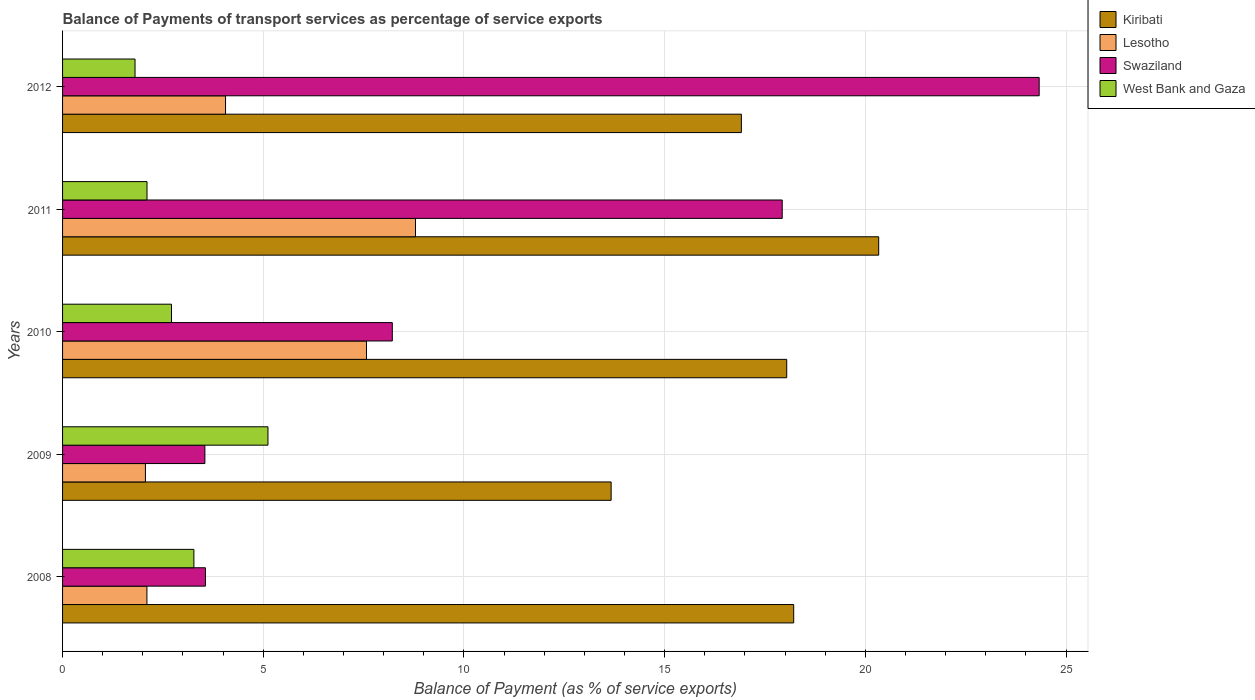How many groups of bars are there?
Your response must be concise. 5. Are the number of bars per tick equal to the number of legend labels?
Your answer should be compact. Yes. How many bars are there on the 2nd tick from the top?
Provide a short and direct response. 4. What is the balance of payments of transport services in Lesotho in 2009?
Provide a short and direct response. 2.06. Across all years, what is the maximum balance of payments of transport services in Lesotho?
Provide a succinct answer. 8.79. Across all years, what is the minimum balance of payments of transport services in West Bank and Gaza?
Your answer should be very brief. 1.81. In which year was the balance of payments of transport services in Lesotho maximum?
Provide a short and direct response. 2011. What is the total balance of payments of transport services in Swaziland in the graph?
Make the answer very short. 57.58. What is the difference between the balance of payments of transport services in Lesotho in 2009 and that in 2012?
Give a very brief answer. -2. What is the difference between the balance of payments of transport services in West Bank and Gaza in 2008 and the balance of payments of transport services in Swaziland in 2012?
Your answer should be compact. -21.06. What is the average balance of payments of transport services in Swaziland per year?
Offer a terse response. 11.52. In the year 2012, what is the difference between the balance of payments of transport services in Lesotho and balance of payments of transport services in West Bank and Gaza?
Ensure brevity in your answer.  2.25. In how many years, is the balance of payments of transport services in Lesotho greater than 17 %?
Your answer should be very brief. 0. What is the ratio of the balance of payments of transport services in Kiribati in 2010 to that in 2012?
Offer a very short reply. 1.07. Is the balance of payments of transport services in Swaziland in 2009 less than that in 2010?
Your answer should be compact. Yes. Is the difference between the balance of payments of transport services in Lesotho in 2009 and 2010 greater than the difference between the balance of payments of transport services in West Bank and Gaza in 2009 and 2010?
Your answer should be compact. No. What is the difference between the highest and the second highest balance of payments of transport services in West Bank and Gaza?
Give a very brief answer. 1.85. What is the difference between the highest and the lowest balance of payments of transport services in Swaziland?
Keep it short and to the point. 20.79. In how many years, is the balance of payments of transport services in Swaziland greater than the average balance of payments of transport services in Swaziland taken over all years?
Keep it short and to the point. 2. Is it the case that in every year, the sum of the balance of payments of transport services in Lesotho and balance of payments of transport services in West Bank and Gaza is greater than the sum of balance of payments of transport services in Swaziland and balance of payments of transport services in Kiribati?
Offer a very short reply. No. What does the 2nd bar from the top in 2010 represents?
Your answer should be compact. Swaziland. What does the 3rd bar from the bottom in 2008 represents?
Keep it short and to the point. Swaziland. How many bars are there?
Ensure brevity in your answer.  20. Are all the bars in the graph horizontal?
Offer a very short reply. Yes. What is the difference between two consecutive major ticks on the X-axis?
Provide a short and direct response. 5. Are the values on the major ticks of X-axis written in scientific E-notation?
Provide a short and direct response. No. How many legend labels are there?
Your response must be concise. 4. How are the legend labels stacked?
Make the answer very short. Vertical. What is the title of the graph?
Your answer should be very brief. Balance of Payments of transport services as percentage of service exports. Does "Paraguay" appear as one of the legend labels in the graph?
Provide a short and direct response. No. What is the label or title of the X-axis?
Make the answer very short. Balance of Payment (as % of service exports). What is the Balance of Payment (as % of service exports) in Kiribati in 2008?
Offer a very short reply. 18.22. What is the Balance of Payment (as % of service exports) of Lesotho in 2008?
Provide a short and direct response. 2.1. What is the Balance of Payment (as % of service exports) in Swaziland in 2008?
Your answer should be very brief. 3.56. What is the Balance of Payment (as % of service exports) in West Bank and Gaza in 2008?
Give a very brief answer. 3.27. What is the Balance of Payment (as % of service exports) in Kiribati in 2009?
Keep it short and to the point. 13.67. What is the Balance of Payment (as % of service exports) in Lesotho in 2009?
Provide a short and direct response. 2.06. What is the Balance of Payment (as % of service exports) in Swaziland in 2009?
Make the answer very short. 3.55. What is the Balance of Payment (as % of service exports) in West Bank and Gaza in 2009?
Give a very brief answer. 5.12. What is the Balance of Payment (as % of service exports) of Kiribati in 2010?
Keep it short and to the point. 18.04. What is the Balance of Payment (as % of service exports) of Lesotho in 2010?
Offer a very short reply. 7.57. What is the Balance of Payment (as % of service exports) of Swaziland in 2010?
Give a very brief answer. 8.22. What is the Balance of Payment (as % of service exports) in West Bank and Gaza in 2010?
Provide a succinct answer. 2.71. What is the Balance of Payment (as % of service exports) in Kiribati in 2011?
Offer a very short reply. 20.33. What is the Balance of Payment (as % of service exports) in Lesotho in 2011?
Provide a succinct answer. 8.79. What is the Balance of Payment (as % of service exports) in Swaziland in 2011?
Give a very brief answer. 17.93. What is the Balance of Payment (as % of service exports) of West Bank and Gaza in 2011?
Make the answer very short. 2.1. What is the Balance of Payment (as % of service exports) in Kiribati in 2012?
Provide a short and direct response. 16.91. What is the Balance of Payment (as % of service exports) in Lesotho in 2012?
Give a very brief answer. 4.06. What is the Balance of Payment (as % of service exports) in Swaziland in 2012?
Give a very brief answer. 24.33. What is the Balance of Payment (as % of service exports) in West Bank and Gaza in 2012?
Make the answer very short. 1.81. Across all years, what is the maximum Balance of Payment (as % of service exports) in Kiribati?
Make the answer very short. 20.33. Across all years, what is the maximum Balance of Payment (as % of service exports) of Lesotho?
Make the answer very short. 8.79. Across all years, what is the maximum Balance of Payment (as % of service exports) of Swaziland?
Provide a succinct answer. 24.33. Across all years, what is the maximum Balance of Payment (as % of service exports) in West Bank and Gaza?
Provide a succinct answer. 5.12. Across all years, what is the minimum Balance of Payment (as % of service exports) of Kiribati?
Your answer should be very brief. 13.67. Across all years, what is the minimum Balance of Payment (as % of service exports) in Lesotho?
Keep it short and to the point. 2.06. Across all years, what is the minimum Balance of Payment (as % of service exports) of Swaziland?
Provide a succinct answer. 3.55. Across all years, what is the minimum Balance of Payment (as % of service exports) in West Bank and Gaza?
Your response must be concise. 1.81. What is the total Balance of Payment (as % of service exports) in Kiribati in the graph?
Keep it short and to the point. 87.17. What is the total Balance of Payment (as % of service exports) of Lesotho in the graph?
Provide a succinct answer. 24.59. What is the total Balance of Payment (as % of service exports) in Swaziland in the graph?
Your answer should be very brief. 57.58. What is the total Balance of Payment (as % of service exports) of West Bank and Gaza in the graph?
Offer a terse response. 15.01. What is the difference between the Balance of Payment (as % of service exports) in Kiribati in 2008 and that in 2009?
Provide a short and direct response. 4.55. What is the difference between the Balance of Payment (as % of service exports) in Lesotho in 2008 and that in 2009?
Give a very brief answer. 0.04. What is the difference between the Balance of Payment (as % of service exports) in Swaziland in 2008 and that in 2009?
Keep it short and to the point. 0.01. What is the difference between the Balance of Payment (as % of service exports) in West Bank and Gaza in 2008 and that in 2009?
Give a very brief answer. -1.85. What is the difference between the Balance of Payment (as % of service exports) in Kiribati in 2008 and that in 2010?
Ensure brevity in your answer.  0.17. What is the difference between the Balance of Payment (as % of service exports) in Lesotho in 2008 and that in 2010?
Provide a short and direct response. -5.47. What is the difference between the Balance of Payment (as % of service exports) of Swaziland in 2008 and that in 2010?
Make the answer very short. -4.66. What is the difference between the Balance of Payment (as % of service exports) in West Bank and Gaza in 2008 and that in 2010?
Offer a very short reply. 0.56. What is the difference between the Balance of Payment (as % of service exports) in Kiribati in 2008 and that in 2011?
Make the answer very short. -2.12. What is the difference between the Balance of Payment (as % of service exports) in Lesotho in 2008 and that in 2011?
Keep it short and to the point. -6.69. What is the difference between the Balance of Payment (as % of service exports) in Swaziland in 2008 and that in 2011?
Provide a succinct answer. -14.37. What is the difference between the Balance of Payment (as % of service exports) of West Bank and Gaza in 2008 and that in 2011?
Make the answer very short. 1.17. What is the difference between the Balance of Payment (as % of service exports) in Kiribati in 2008 and that in 2012?
Your response must be concise. 1.3. What is the difference between the Balance of Payment (as % of service exports) of Lesotho in 2008 and that in 2012?
Give a very brief answer. -1.96. What is the difference between the Balance of Payment (as % of service exports) in Swaziland in 2008 and that in 2012?
Ensure brevity in your answer.  -20.77. What is the difference between the Balance of Payment (as % of service exports) in West Bank and Gaza in 2008 and that in 2012?
Provide a succinct answer. 1.47. What is the difference between the Balance of Payment (as % of service exports) of Kiribati in 2009 and that in 2010?
Offer a very short reply. -4.37. What is the difference between the Balance of Payment (as % of service exports) of Lesotho in 2009 and that in 2010?
Make the answer very short. -5.51. What is the difference between the Balance of Payment (as % of service exports) of Swaziland in 2009 and that in 2010?
Offer a very short reply. -4.67. What is the difference between the Balance of Payment (as % of service exports) in West Bank and Gaza in 2009 and that in 2010?
Your response must be concise. 2.4. What is the difference between the Balance of Payment (as % of service exports) in Kiribati in 2009 and that in 2011?
Your response must be concise. -6.67. What is the difference between the Balance of Payment (as % of service exports) in Lesotho in 2009 and that in 2011?
Provide a succinct answer. -6.73. What is the difference between the Balance of Payment (as % of service exports) of Swaziland in 2009 and that in 2011?
Give a very brief answer. -14.38. What is the difference between the Balance of Payment (as % of service exports) in West Bank and Gaza in 2009 and that in 2011?
Give a very brief answer. 3.01. What is the difference between the Balance of Payment (as % of service exports) of Kiribati in 2009 and that in 2012?
Your answer should be compact. -3.24. What is the difference between the Balance of Payment (as % of service exports) of Lesotho in 2009 and that in 2012?
Offer a very short reply. -2. What is the difference between the Balance of Payment (as % of service exports) in Swaziland in 2009 and that in 2012?
Give a very brief answer. -20.79. What is the difference between the Balance of Payment (as % of service exports) of West Bank and Gaza in 2009 and that in 2012?
Your answer should be very brief. 3.31. What is the difference between the Balance of Payment (as % of service exports) of Kiribati in 2010 and that in 2011?
Your response must be concise. -2.29. What is the difference between the Balance of Payment (as % of service exports) in Lesotho in 2010 and that in 2011?
Give a very brief answer. -1.22. What is the difference between the Balance of Payment (as % of service exports) of Swaziland in 2010 and that in 2011?
Keep it short and to the point. -9.71. What is the difference between the Balance of Payment (as % of service exports) in West Bank and Gaza in 2010 and that in 2011?
Offer a terse response. 0.61. What is the difference between the Balance of Payment (as % of service exports) in Kiribati in 2010 and that in 2012?
Give a very brief answer. 1.13. What is the difference between the Balance of Payment (as % of service exports) of Lesotho in 2010 and that in 2012?
Offer a very short reply. 3.51. What is the difference between the Balance of Payment (as % of service exports) in Swaziland in 2010 and that in 2012?
Keep it short and to the point. -16.12. What is the difference between the Balance of Payment (as % of service exports) in West Bank and Gaza in 2010 and that in 2012?
Your answer should be compact. 0.91. What is the difference between the Balance of Payment (as % of service exports) of Kiribati in 2011 and that in 2012?
Offer a terse response. 3.42. What is the difference between the Balance of Payment (as % of service exports) of Lesotho in 2011 and that in 2012?
Your answer should be very brief. 4.73. What is the difference between the Balance of Payment (as % of service exports) in Swaziland in 2011 and that in 2012?
Offer a terse response. -6.4. What is the difference between the Balance of Payment (as % of service exports) in West Bank and Gaza in 2011 and that in 2012?
Offer a terse response. 0.3. What is the difference between the Balance of Payment (as % of service exports) of Kiribati in 2008 and the Balance of Payment (as % of service exports) of Lesotho in 2009?
Provide a short and direct response. 16.15. What is the difference between the Balance of Payment (as % of service exports) in Kiribati in 2008 and the Balance of Payment (as % of service exports) in Swaziland in 2009?
Provide a short and direct response. 14.67. What is the difference between the Balance of Payment (as % of service exports) of Kiribati in 2008 and the Balance of Payment (as % of service exports) of West Bank and Gaza in 2009?
Your answer should be compact. 13.1. What is the difference between the Balance of Payment (as % of service exports) in Lesotho in 2008 and the Balance of Payment (as % of service exports) in Swaziland in 2009?
Your answer should be compact. -1.44. What is the difference between the Balance of Payment (as % of service exports) of Lesotho in 2008 and the Balance of Payment (as % of service exports) of West Bank and Gaza in 2009?
Offer a terse response. -3.02. What is the difference between the Balance of Payment (as % of service exports) in Swaziland in 2008 and the Balance of Payment (as % of service exports) in West Bank and Gaza in 2009?
Your response must be concise. -1.56. What is the difference between the Balance of Payment (as % of service exports) of Kiribati in 2008 and the Balance of Payment (as % of service exports) of Lesotho in 2010?
Provide a short and direct response. 10.64. What is the difference between the Balance of Payment (as % of service exports) in Kiribati in 2008 and the Balance of Payment (as % of service exports) in Swaziland in 2010?
Your answer should be compact. 10. What is the difference between the Balance of Payment (as % of service exports) in Kiribati in 2008 and the Balance of Payment (as % of service exports) in West Bank and Gaza in 2010?
Your answer should be compact. 15.5. What is the difference between the Balance of Payment (as % of service exports) in Lesotho in 2008 and the Balance of Payment (as % of service exports) in Swaziland in 2010?
Provide a succinct answer. -6.11. What is the difference between the Balance of Payment (as % of service exports) of Lesotho in 2008 and the Balance of Payment (as % of service exports) of West Bank and Gaza in 2010?
Keep it short and to the point. -0.61. What is the difference between the Balance of Payment (as % of service exports) in Swaziland in 2008 and the Balance of Payment (as % of service exports) in West Bank and Gaza in 2010?
Make the answer very short. 0.85. What is the difference between the Balance of Payment (as % of service exports) in Kiribati in 2008 and the Balance of Payment (as % of service exports) in Lesotho in 2011?
Offer a very short reply. 9.42. What is the difference between the Balance of Payment (as % of service exports) in Kiribati in 2008 and the Balance of Payment (as % of service exports) in Swaziland in 2011?
Ensure brevity in your answer.  0.29. What is the difference between the Balance of Payment (as % of service exports) of Kiribati in 2008 and the Balance of Payment (as % of service exports) of West Bank and Gaza in 2011?
Ensure brevity in your answer.  16.11. What is the difference between the Balance of Payment (as % of service exports) in Lesotho in 2008 and the Balance of Payment (as % of service exports) in Swaziland in 2011?
Offer a terse response. -15.83. What is the difference between the Balance of Payment (as % of service exports) in Lesotho in 2008 and the Balance of Payment (as % of service exports) in West Bank and Gaza in 2011?
Your response must be concise. -0. What is the difference between the Balance of Payment (as % of service exports) in Swaziland in 2008 and the Balance of Payment (as % of service exports) in West Bank and Gaza in 2011?
Offer a terse response. 1.46. What is the difference between the Balance of Payment (as % of service exports) of Kiribati in 2008 and the Balance of Payment (as % of service exports) of Lesotho in 2012?
Your answer should be very brief. 14.16. What is the difference between the Balance of Payment (as % of service exports) in Kiribati in 2008 and the Balance of Payment (as % of service exports) in Swaziland in 2012?
Your response must be concise. -6.12. What is the difference between the Balance of Payment (as % of service exports) of Kiribati in 2008 and the Balance of Payment (as % of service exports) of West Bank and Gaza in 2012?
Your response must be concise. 16.41. What is the difference between the Balance of Payment (as % of service exports) in Lesotho in 2008 and the Balance of Payment (as % of service exports) in Swaziland in 2012?
Provide a succinct answer. -22.23. What is the difference between the Balance of Payment (as % of service exports) of Lesotho in 2008 and the Balance of Payment (as % of service exports) of West Bank and Gaza in 2012?
Your answer should be compact. 0.3. What is the difference between the Balance of Payment (as % of service exports) of Swaziland in 2008 and the Balance of Payment (as % of service exports) of West Bank and Gaza in 2012?
Provide a succinct answer. 1.75. What is the difference between the Balance of Payment (as % of service exports) in Kiribati in 2009 and the Balance of Payment (as % of service exports) in Lesotho in 2010?
Provide a short and direct response. 6.1. What is the difference between the Balance of Payment (as % of service exports) in Kiribati in 2009 and the Balance of Payment (as % of service exports) in Swaziland in 2010?
Your answer should be compact. 5.45. What is the difference between the Balance of Payment (as % of service exports) in Kiribati in 2009 and the Balance of Payment (as % of service exports) in West Bank and Gaza in 2010?
Offer a very short reply. 10.95. What is the difference between the Balance of Payment (as % of service exports) of Lesotho in 2009 and the Balance of Payment (as % of service exports) of Swaziland in 2010?
Your answer should be compact. -6.15. What is the difference between the Balance of Payment (as % of service exports) in Lesotho in 2009 and the Balance of Payment (as % of service exports) in West Bank and Gaza in 2010?
Offer a terse response. -0.65. What is the difference between the Balance of Payment (as % of service exports) of Swaziland in 2009 and the Balance of Payment (as % of service exports) of West Bank and Gaza in 2010?
Ensure brevity in your answer.  0.83. What is the difference between the Balance of Payment (as % of service exports) of Kiribati in 2009 and the Balance of Payment (as % of service exports) of Lesotho in 2011?
Ensure brevity in your answer.  4.87. What is the difference between the Balance of Payment (as % of service exports) of Kiribati in 2009 and the Balance of Payment (as % of service exports) of Swaziland in 2011?
Make the answer very short. -4.26. What is the difference between the Balance of Payment (as % of service exports) of Kiribati in 2009 and the Balance of Payment (as % of service exports) of West Bank and Gaza in 2011?
Ensure brevity in your answer.  11.56. What is the difference between the Balance of Payment (as % of service exports) in Lesotho in 2009 and the Balance of Payment (as % of service exports) in Swaziland in 2011?
Your answer should be very brief. -15.87. What is the difference between the Balance of Payment (as % of service exports) in Lesotho in 2009 and the Balance of Payment (as % of service exports) in West Bank and Gaza in 2011?
Offer a terse response. -0.04. What is the difference between the Balance of Payment (as % of service exports) of Swaziland in 2009 and the Balance of Payment (as % of service exports) of West Bank and Gaza in 2011?
Give a very brief answer. 1.44. What is the difference between the Balance of Payment (as % of service exports) in Kiribati in 2009 and the Balance of Payment (as % of service exports) in Lesotho in 2012?
Provide a short and direct response. 9.61. What is the difference between the Balance of Payment (as % of service exports) of Kiribati in 2009 and the Balance of Payment (as % of service exports) of Swaziland in 2012?
Make the answer very short. -10.66. What is the difference between the Balance of Payment (as % of service exports) in Kiribati in 2009 and the Balance of Payment (as % of service exports) in West Bank and Gaza in 2012?
Make the answer very short. 11.86. What is the difference between the Balance of Payment (as % of service exports) of Lesotho in 2009 and the Balance of Payment (as % of service exports) of Swaziland in 2012?
Ensure brevity in your answer.  -22.27. What is the difference between the Balance of Payment (as % of service exports) of Lesotho in 2009 and the Balance of Payment (as % of service exports) of West Bank and Gaza in 2012?
Your answer should be compact. 0.26. What is the difference between the Balance of Payment (as % of service exports) of Swaziland in 2009 and the Balance of Payment (as % of service exports) of West Bank and Gaza in 2012?
Your response must be concise. 1.74. What is the difference between the Balance of Payment (as % of service exports) in Kiribati in 2010 and the Balance of Payment (as % of service exports) in Lesotho in 2011?
Offer a very short reply. 9.25. What is the difference between the Balance of Payment (as % of service exports) of Kiribati in 2010 and the Balance of Payment (as % of service exports) of Swaziland in 2011?
Offer a very short reply. 0.11. What is the difference between the Balance of Payment (as % of service exports) of Kiribati in 2010 and the Balance of Payment (as % of service exports) of West Bank and Gaza in 2011?
Offer a terse response. 15.94. What is the difference between the Balance of Payment (as % of service exports) in Lesotho in 2010 and the Balance of Payment (as % of service exports) in Swaziland in 2011?
Offer a terse response. -10.36. What is the difference between the Balance of Payment (as % of service exports) in Lesotho in 2010 and the Balance of Payment (as % of service exports) in West Bank and Gaza in 2011?
Make the answer very short. 5.47. What is the difference between the Balance of Payment (as % of service exports) in Swaziland in 2010 and the Balance of Payment (as % of service exports) in West Bank and Gaza in 2011?
Ensure brevity in your answer.  6.11. What is the difference between the Balance of Payment (as % of service exports) in Kiribati in 2010 and the Balance of Payment (as % of service exports) in Lesotho in 2012?
Your response must be concise. 13.98. What is the difference between the Balance of Payment (as % of service exports) in Kiribati in 2010 and the Balance of Payment (as % of service exports) in Swaziland in 2012?
Offer a very short reply. -6.29. What is the difference between the Balance of Payment (as % of service exports) of Kiribati in 2010 and the Balance of Payment (as % of service exports) of West Bank and Gaza in 2012?
Ensure brevity in your answer.  16.24. What is the difference between the Balance of Payment (as % of service exports) in Lesotho in 2010 and the Balance of Payment (as % of service exports) in Swaziland in 2012?
Your answer should be very brief. -16.76. What is the difference between the Balance of Payment (as % of service exports) of Lesotho in 2010 and the Balance of Payment (as % of service exports) of West Bank and Gaza in 2012?
Make the answer very short. 5.77. What is the difference between the Balance of Payment (as % of service exports) of Swaziland in 2010 and the Balance of Payment (as % of service exports) of West Bank and Gaza in 2012?
Give a very brief answer. 6.41. What is the difference between the Balance of Payment (as % of service exports) of Kiribati in 2011 and the Balance of Payment (as % of service exports) of Lesotho in 2012?
Your response must be concise. 16.27. What is the difference between the Balance of Payment (as % of service exports) in Kiribati in 2011 and the Balance of Payment (as % of service exports) in Swaziland in 2012?
Make the answer very short. -4. What is the difference between the Balance of Payment (as % of service exports) of Kiribati in 2011 and the Balance of Payment (as % of service exports) of West Bank and Gaza in 2012?
Offer a very short reply. 18.53. What is the difference between the Balance of Payment (as % of service exports) of Lesotho in 2011 and the Balance of Payment (as % of service exports) of Swaziland in 2012?
Give a very brief answer. -15.54. What is the difference between the Balance of Payment (as % of service exports) in Lesotho in 2011 and the Balance of Payment (as % of service exports) in West Bank and Gaza in 2012?
Ensure brevity in your answer.  6.99. What is the difference between the Balance of Payment (as % of service exports) in Swaziland in 2011 and the Balance of Payment (as % of service exports) in West Bank and Gaza in 2012?
Keep it short and to the point. 16.12. What is the average Balance of Payment (as % of service exports) in Kiribati per year?
Provide a short and direct response. 17.43. What is the average Balance of Payment (as % of service exports) of Lesotho per year?
Provide a short and direct response. 4.92. What is the average Balance of Payment (as % of service exports) of Swaziland per year?
Provide a short and direct response. 11.52. What is the average Balance of Payment (as % of service exports) of West Bank and Gaza per year?
Provide a succinct answer. 3. In the year 2008, what is the difference between the Balance of Payment (as % of service exports) in Kiribati and Balance of Payment (as % of service exports) in Lesotho?
Provide a short and direct response. 16.11. In the year 2008, what is the difference between the Balance of Payment (as % of service exports) of Kiribati and Balance of Payment (as % of service exports) of Swaziland?
Your answer should be very brief. 14.66. In the year 2008, what is the difference between the Balance of Payment (as % of service exports) of Kiribati and Balance of Payment (as % of service exports) of West Bank and Gaza?
Offer a very short reply. 14.94. In the year 2008, what is the difference between the Balance of Payment (as % of service exports) of Lesotho and Balance of Payment (as % of service exports) of Swaziland?
Offer a terse response. -1.46. In the year 2008, what is the difference between the Balance of Payment (as % of service exports) of Lesotho and Balance of Payment (as % of service exports) of West Bank and Gaza?
Keep it short and to the point. -1.17. In the year 2008, what is the difference between the Balance of Payment (as % of service exports) of Swaziland and Balance of Payment (as % of service exports) of West Bank and Gaza?
Your answer should be very brief. 0.29. In the year 2009, what is the difference between the Balance of Payment (as % of service exports) of Kiribati and Balance of Payment (as % of service exports) of Lesotho?
Make the answer very short. 11.6. In the year 2009, what is the difference between the Balance of Payment (as % of service exports) in Kiribati and Balance of Payment (as % of service exports) in Swaziland?
Your answer should be very brief. 10.12. In the year 2009, what is the difference between the Balance of Payment (as % of service exports) in Kiribati and Balance of Payment (as % of service exports) in West Bank and Gaza?
Your response must be concise. 8.55. In the year 2009, what is the difference between the Balance of Payment (as % of service exports) of Lesotho and Balance of Payment (as % of service exports) of Swaziland?
Keep it short and to the point. -1.48. In the year 2009, what is the difference between the Balance of Payment (as % of service exports) of Lesotho and Balance of Payment (as % of service exports) of West Bank and Gaza?
Your response must be concise. -3.05. In the year 2009, what is the difference between the Balance of Payment (as % of service exports) in Swaziland and Balance of Payment (as % of service exports) in West Bank and Gaza?
Keep it short and to the point. -1.57. In the year 2010, what is the difference between the Balance of Payment (as % of service exports) in Kiribati and Balance of Payment (as % of service exports) in Lesotho?
Provide a short and direct response. 10.47. In the year 2010, what is the difference between the Balance of Payment (as % of service exports) of Kiribati and Balance of Payment (as % of service exports) of Swaziland?
Keep it short and to the point. 9.83. In the year 2010, what is the difference between the Balance of Payment (as % of service exports) of Kiribati and Balance of Payment (as % of service exports) of West Bank and Gaza?
Give a very brief answer. 15.33. In the year 2010, what is the difference between the Balance of Payment (as % of service exports) in Lesotho and Balance of Payment (as % of service exports) in Swaziland?
Make the answer very short. -0.64. In the year 2010, what is the difference between the Balance of Payment (as % of service exports) of Lesotho and Balance of Payment (as % of service exports) of West Bank and Gaza?
Give a very brief answer. 4.86. In the year 2010, what is the difference between the Balance of Payment (as % of service exports) of Swaziland and Balance of Payment (as % of service exports) of West Bank and Gaza?
Provide a succinct answer. 5.5. In the year 2011, what is the difference between the Balance of Payment (as % of service exports) in Kiribati and Balance of Payment (as % of service exports) in Lesotho?
Provide a short and direct response. 11.54. In the year 2011, what is the difference between the Balance of Payment (as % of service exports) of Kiribati and Balance of Payment (as % of service exports) of Swaziland?
Your answer should be very brief. 2.4. In the year 2011, what is the difference between the Balance of Payment (as % of service exports) of Kiribati and Balance of Payment (as % of service exports) of West Bank and Gaza?
Offer a very short reply. 18.23. In the year 2011, what is the difference between the Balance of Payment (as % of service exports) in Lesotho and Balance of Payment (as % of service exports) in Swaziland?
Keep it short and to the point. -9.14. In the year 2011, what is the difference between the Balance of Payment (as % of service exports) in Lesotho and Balance of Payment (as % of service exports) in West Bank and Gaza?
Keep it short and to the point. 6.69. In the year 2011, what is the difference between the Balance of Payment (as % of service exports) in Swaziland and Balance of Payment (as % of service exports) in West Bank and Gaza?
Your answer should be compact. 15.83. In the year 2012, what is the difference between the Balance of Payment (as % of service exports) of Kiribati and Balance of Payment (as % of service exports) of Lesotho?
Your answer should be compact. 12.85. In the year 2012, what is the difference between the Balance of Payment (as % of service exports) in Kiribati and Balance of Payment (as % of service exports) in Swaziland?
Provide a succinct answer. -7.42. In the year 2012, what is the difference between the Balance of Payment (as % of service exports) of Kiribati and Balance of Payment (as % of service exports) of West Bank and Gaza?
Your answer should be compact. 15.11. In the year 2012, what is the difference between the Balance of Payment (as % of service exports) in Lesotho and Balance of Payment (as % of service exports) in Swaziland?
Keep it short and to the point. -20.27. In the year 2012, what is the difference between the Balance of Payment (as % of service exports) in Lesotho and Balance of Payment (as % of service exports) in West Bank and Gaza?
Ensure brevity in your answer.  2.25. In the year 2012, what is the difference between the Balance of Payment (as % of service exports) in Swaziland and Balance of Payment (as % of service exports) in West Bank and Gaza?
Ensure brevity in your answer.  22.53. What is the ratio of the Balance of Payment (as % of service exports) in Kiribati in 2008 to that in 2009?
Provide a succinct answer. 1.33. What is the ratio of the Balance of Payment (as % of service exports) in Lesotho in 2008 to that in 2009?
Give a very brief answer. 1.02. What is the ratio of the Balance of Payment (as % of service exports) in Swaziland in 2008 to that in 2009?
Your response must be concise. 1. What is the ratio of the Balance of Payment (as % of service exports) of West Bank and Gaza in 2008 to that in 2009?
Provide a succinct answer. 0.64. What is the ratio of the Balance of Payment (as % of service exports) in Kiribati in 2008 to that in 2010?
Make the answer very short. 1.01. What is the ratio of the Balance of Payment (as % of service exports) of Lesotho in 2008 to that in 2010?
Provide a succinct answer. 0.28. What is the ratio of the Balance of Payment (as % of service exports) in Swaziland in 2008 to that in 2010?
Your answer should be compact. 0.43. What is the ratio of the Balance of Payment (as % of service exports) of West Bank and Gaza in 2008 to that in 2010?
Ensure brevity in your answer.  1.21. What is the ratio of the Balance of Payment (as % of service exports) of Kiribati in 2008 to that in 2011?
Offer a very short reply. 0.9. What is the ratio of the Balance of Payment (as % of service exports) of Lesotho in 2008 to that in 2011?
Offer a terse response. 0.24. What is the ratio of the Balance of Payment (as % of service exports) in Swaziland in 2008 to that in 2011?
Give a very brief answer. 0.2. What is the ratio of the Balance of Payment (as % of service exports) in West Bank and Gaza in 2008 to that in 2011?
Provide a succinct answer. 1.56. What is the ratio of the Balance of Payment (as % of service exports) in Kiribati in 2008 to that in 2012?
Provide a short and direct response. 1.08. What is the ratio of the Balance of Payment (as % of service exports) of Lesotho in 2008 to that in 2012?
Your answer should be very brief. 0.52. What is the ratio of the Balance of Payment (as % of service exports) of Swaziland in 2008 to that in 2012?
Your answer should be compact. 0.15. What is the ratio of the Balance of Payment (as % of service exports) of West Bank and Gaza in 2008 to that in 2012?
Your answer should be very brief. 1.81. What is the ratio of the Balance of Payment (as % of service exports) in Kiribati in 2009 to that in 2010?
Provide a short and direct response. 0.76. What is the ratio of the Balance of Payment (as % of service exports) in Lesotho in 2009 to that in 2010?
Keep it short and to the point. 0.27. What is the ratio of the Balance of Payment (as % of service exports) in Swaziland in 2009 to that in 2010?
Your response must be concise. 0.43. What is the ratio of the Balance of Payment (as % of service exports) in West Bank and Gaza in 2009 to that in 2010?
Your answer should be very brief. 1.89. What is the ratio of the Balance of Payment (as % of service exports) in Kiribati in 2009 to that in 2011?
Ensure brevity in your answer.  0.67. What is the ratio of the Balance of Payment (as % of service exports) in Lesotho in 2009 to that in 2011?
Offer a very short reply. 0.23. What is the ratio of the Balance of Payment (as % of service exports) in Swaziland in 2009 to that in 2011?
Offer a terse response. 0.2. What is the ratio of the Balance of Payment (as % of service exports) of West Bank and Gaza in 2009 to that in 2011?
Provide a succinct answer. 2.43. What is the ratio of the Balance of Payment (as % of service exports) of Kiribati in 2009 to that in 2012?
Your answer should be very brief. 0.81. What is the ratio of the Balance of Payment (as % of service exports) of Lesotho in 2009 to that in 2012?
Your response must be concise. 0.51. What is the ratio of the Balance of Payment (as % of service exports) in Swaziland in 2009 to that in 2012?
Offer a very short reply. 0.15. What is the ratio of the Balance of Payment (as % of service exports) of West Bank and Gaza in 2009 to that in 2012?
Your answer should be very brief. 2.83. What is the ratio of the Balance of Payment (as % of service exports) in Kiribati in 2010 to that in 2011?
Offer a very short reply. 0.89. What is the ratio of the Balance of Payment (as % of service exports) of Lesotho in 2010 to that in 2011?
Offer a terse response. 0.86. What is the ratio of the Balance of Payment (as % of service exports) of Swaziland in 2010 to that in 2011?
Your answer should be very brief. 0.46. What is the ratio of the Balance of Payment (as % of service exports) in West Bank and Gaza in 2010 to that in 2011?
Ensure brevity in your answer.  1.29. What is the ratio of the Balance of Payment (as % of service exports) in Kiribati in 2010 to that in 2012?
Provide a short and direct response. 1.07. What is the ratio of the Balance of Payment (as % of service exports) of Lesotho in 2010 to that in 2012?
Your response must be concise. 1.86. What is the ratio of the Balance of Payment (as % of service exports) in Swaziland in 2010 to that in 2012?
Offer a terse response. 0.34. What is the ratio of the Balance of Payment (as % of service exports) of West Bank and Gaza in 2010 to that in 2012?
Your answer should be compact. 1.5. What is the ratio of the Balance of Payment (as % of service exports) of Kiribati in 2011 to that in 2012?
Provide a short and direct response. 1.2. What is the ratio of the Balance of Payment (as % of service exports) in Lesotho in 2011 to that in 2012?
Make the answer very short. 2.17. What is the ratio of the Balance of Payment (as % of service exports) of Swaziland in 2011 to that in 2012?
Offer a very short reply. 0.74. What is the ratio of the Balance of Payment (as % of service exports) in West Bank and Gaza in 2011 to that in 2012?
Your answer should be compact. 1.17. What is the difference between the highest and the second highest Balance of Payment (as % of service exports) in Kiribati?
Make the answer very short. 2.12. What is the difference between the highest and the second highest Balance of Payment (as % of service exports) of Lesotho?
Your response must be concise. 1.22. What is the difference between the highest and the second highest Balance of Payment (as % of service exports) in Swaziland?
Your answer should be compact. 6.4. What is the difference between the highest and the second highest Balance of Payment (as % of service exports) of West Bank and Gaza?
Your answer should be very brief. 1.85. What is the difference between the highest and the lowest Balance of Payment (as % of service exports) in Kiribati?
Offer a very short reply. 6.67. What is the difference between the highest and the lowest Balance of Payment (as % of service exports) in Lesotho?
Keep it short and to the point. 6.73. What is the difference between the highest and the lowest Balance of Payment (as % of service exports) in Swaziland?
Make the answer very short. 20.79. What is the difference between the highest and the lowest Balance of Payment (as % of service exports) in West Bank and Gaza?
Provide a succinct answer. 3.31. 